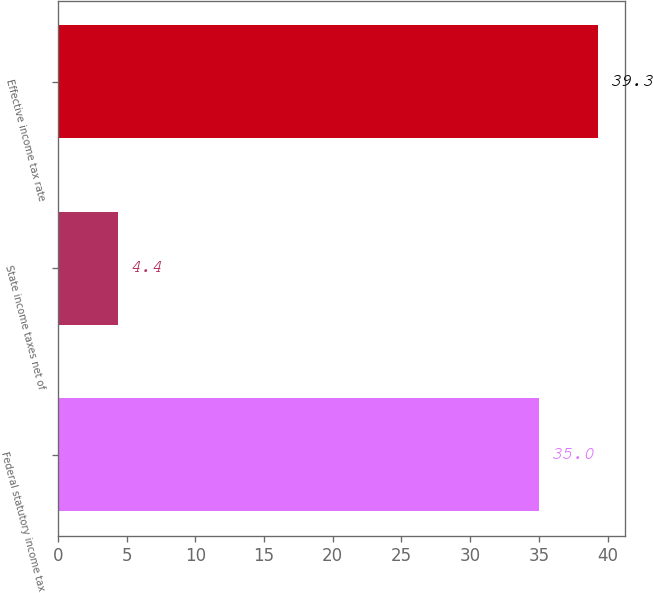<chart> <loc_0><loc_0><loc_500><loc_500><bar_chart><fcel>Federal statutory income tax<fcel>State income taxes net of<fcel>Effective income tax rate<nl><fcel>35<fcel>4.4<fcel>39.3<nl></chart> 